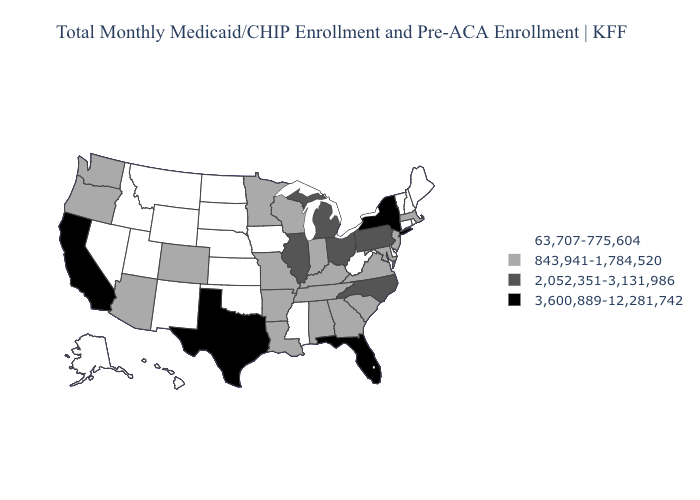Name the states that have a value in the range 2,052,351-3,131,986?
Quick response, please. Illinois, Michigan, North Carolina, Ohio, Pennsylvania. What is the value of Tennessee?
Give a very brief answer. 843,941-1,784,520. Does Nevada have a lower value than New Mexico?
Write a very short answer. No. Among the states that border Oklahoma , which have the highest value?
Quick response, please. Texas. Name the states that have a value in the range 2,052,351-3,131,986?
Quick response, please. Illinois, Michigan, North Carolina, Ohio, Pennsylvania. Name the states that have a value in the range 843,941-1,784,520?
Be succinct. Alabama, Arizona, Arkansas, Colorado, Georgia, Indiana, Kentucky, Louisiana, Maryland, Massachusetts, Minnesota, Missouri, New Jersey, Oregon, South Carolina, Tennessee, Virginia, Washington, Wisconsin. Does New York have the highest value in the Northeast?
Quick response, please. Yes. What is the highest value in the USA?
Write a very short answer. 3,600,889-12,281,742. Among the states that border Maryland , which have the highest value?
Give a very brief answer. Pennsylvania. What is the value of Maryland?
Answer briefly. 843,941-1,784,520. Among the states that border Michigan , does Indiana have the highest value?
Keep it brief. No. What is the value of Oklahoma?
Keep it brief. 63,707-775,604. Among the states that border Missouri , which have the lowest value?
Be succinct. Iowa, Kansas, Nebraska, Oklahoma. What is the lowest value in states that border Iowa?
Keep it brief. 63,707-775,604. Does Kentucky have a higher value than Wisconsin?
Answer briefly. No. 